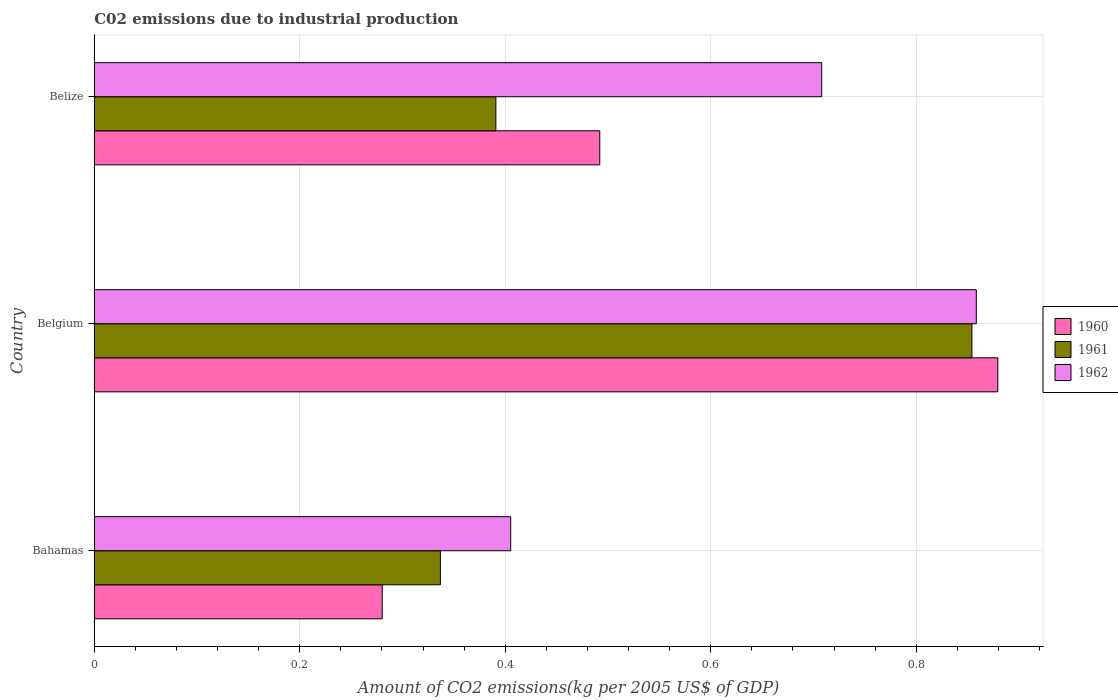How many groups of bars are there?
Your answer should be compact. 3. Are the number of bars on each tick of the Y-axis equal?
Your answer should be very brief. Yes. What is the label of the 1st group of bars from the top?
Your response must be concise. Belize. In how many cases, is the number of bars for a given country not equal to the number of legend labels?
Keep it short and to the point. 0. What is the amount of CO2 emitted due to industrial production in 1960 in Belize?
Keep it short and to the point. 0.49. Across all countries, what is the maximum amount of CO2 emitted due to industrial production in 1961?
Provide a succinct answer. 0.85. Across all countries, what is the minimum amount of CO2 emitted due to industrial production in 1961?
Your answer should be very brief. 0.34. In which country was the amount of CO2 emitted due to industrial production in 1960 maximum?
Your answer should be very brief. Belgium. In which country was the amount of CO2 emitted due to industrial production in 1962 minimum?
Make the answer very short. Bahamas. What is the total amount of CO2 emitted due to industrial production in 1961 in the graph?
Provide a short and direct response. 1.58. What is the difference between the amount of CO2 emitted due to industrial production in 1961 in Bahamas and that in Belgium?
Ensure brevity in your answer.  -0.52. What is the difference between the amount of CO2 emitted due to industrial production in 1961 in Bahamas and the amount of CO2 emitted due to industrial production in 1960 in Belize?
Provide a succinct answer. -0.16. What is the average amount of CO2 emitted due to industrial production in 1960 per country?
Offer a very short reply. 0.55. What is the difference between the amount of CO2 emitted due to industrial production in 1961 and amount of CO2 emitted due to industrial production in 1962 in Bahamas?
Your answer should be compact. -0.07. What is the ratio of the amount of CO2 emitted due to industrial production in 1961 in Bahamas to that in Belgium?
Make the answer very short. 0.39. Is the difference between the amount of CO2 emitted due to industrial production in 1961 in Bahamas and Belgium greater than the difference between the amount of CO2 emitted due to industrial production in 1962 in Bahamas and Belgium?
Your answer should be very brief. No. What is the difference between the highest and the second highest amount of CO2 emitted due to industrial production in 1961?
Provide a short and direct response. 0.46. What is the difference between the highest and the lowest amount of CO2 emitted due to industrial production in 1962?
Provide a succinct answer. 0.45. What does the 1st bar from the bottom in Belize represents?
Keep it short and to the point. 1960. How many bars are there?
Provide a succinct answer. 9. Are all the bars in the graph horizontal?
Keep it short and to the point. Yes. How many countries are there in the graph?
Ensure brevity in your answer.  3. What is the difference between two consecutive major ticks on the X-axis?
Your response must be concise. 0.2. Are the values on the major ticks of X-axis written in scientific E-notation?
Your answer should be very brief. No. Does the graph contain any zero values?
Provide a short and direct response. No. Does the graph contain grids?
Your response must be concise. Yes. How many legend labels are there?
Give a very brief answer. 3. What is the title of the graph?
Your response must be concise. C02 emissions due to industrial production. What is the label or title of the X-axis?
Your answer should be compact. Amount of CO2 emissions(kg per 2005 US$ of GDP). What is the label or title of the Y-axis?
Your response must be concise. Country. What is the Amount of CO2 emissions(kg per 2005 US$ of GDP) of 1960 in Bahamas?
Make the answer very short. 0.28. What is the Amount of CO2 emissions(kg per 2005 US$ of GDP) of 1961 in Bahamas?
Provide a succinct answer. 0.34. What is the Amount of CO2 emissions(kg per 2005 US$ of GDP) of 1962 in Bahamas?
Provide a succinct answer. 0.41. What is the Amount of CO2 emissions(kg per 2005 US$ of GDP) of 1960 in Belgium?
Provide a succinct answer. 0.88. What is the Amount of CO2 emissions(kg per 2005 US$ of GDP) of 1961 in Belgium?
Give a very brief answer. 0.85. What is the Amount of CO2 emissions(kg per 2005 US$ of GDP) in 1962 in Belgium?
Make the answer very short. 0.86. What is the Amount of CO2 emissions(kg per 2005 US$ of GDP) of 1960 in Belize?
Keep it short and to the point. 0.49. What is the Amount of CO2 emissions(kg per 2005 US$ of GDP) of 1961 in Belize?
Offer a very short reply. 0.39. What is the Amount of CO2 emissions(kg per 2005 US$ of GDP) in 1962 in Belize?
Ensure brevity in your answer.  0.71. Across all countries, what is the maximum Amount of CO2 emissions(kg per 2005 US$ of GDP) in 1960?
Your response must be concise. 0.88. Across all countries, what is the maximum Amount of CO2 emissions(kg per 2005 US$ of GDP) in 1961?
Your answer should be compact. 0.85. Across all countries, what is the maximum Amount of CO2 emissions(kg per 2005 US$ of GDP) in 1962?
Give a very brief answer. 0.86. Across all countries, what is the minimum Amount of CO2 emissions(kg per 2005 US$ of GDP) of 1960?
Provide a short and direct response. 0.28. Across all countries, what is the minimum Amount of CO2 emissions(kg per 2005 US$ of GDP) of 1961?
Offer a terse response. 0.34. Across all countries, what is the minimum Amount of CO2 emissions(kg per 2005 US$ of GDP) of 1962?
Give a very brief answer. 0.41. What is the total Amount of CO2 emissions(kg per 2005 US$ of GDP) of 1960 in the graph?
Ensure brevity in your answer.  1.65. What is the total Amount of CO2 emissions(kg per 2005 US$ of GDP) of 1961 in the graph?
Offer a very short reply. 1.58. What is the total Amount of CO2 emissions(kg per 2005 US$ of GDP) of 1962 in the graph?
Offer a very short reply. 1.97. What is the difference between the Amount of CO2 emissions(kg per 2005 US$ of GDP) in 1960 in Bahamas and that in Belgium?
Ensure brevity in your answer.  -0.6. What is the difference between the Amount of CO2 emissions(kg per 2005 US$ of GDP) in 1961 in Bahamas and that in Belgium?
Your answer should be compact. -0.52. What is the difference between the Amount of CO2 emissions(kg per 2005 US$ of GDP) of 1962 in Bahamas and that in Belgium?
Offer a terse response. -0.45. What is the difference between the Amount of CO2 emissions(kg per 2005 US$ of GDP) in 1960 in Bahamas and that in Belize?
Provide a short and direct response. -0.21. What is the difference between the Amount of CO2 emissions(kg per 2005 US$ of GDP) in 1961 in Bahamas and that in Belize?
Provide a succinct answer. -0.05. What is the difference between the Amount of CO2 emissions(kg per 2005 US$ of GDP) in 1962 in Bahamas and that in Belize?
Provide a succinct answer. -0.3. What is the difference between the Amount of CO2 emissions(kg per 2005 US$ of GDP) of 1960 in Belgium and that in Belize?
Ensure brevity in your answer.  0.39. What is the difference between the Amount of CO2 emissions(kg per 2005 US$ of GDP) in 1961 in Belgium and that in Belize?
Your response must be concise. 0.46. What is the difference between the Amount of CO2 emissions(kg per 2005 US$ of GDP) of 1962 in Belgium and that in Belize?
Give a very brief answer. 0.15. What is the difference between the Amount of CO2 emissions(kg per 2005 US$ of GDP) in 1960 in Bahamas and the Amount of CO2 emissions(kg per 2005 US$ of GDP) in 1961 in Belgium?
Ensure brevity in your answer.  -0.57. What is the difference between the Amount of CO2 emissions(kg per 2005 US$ of GDP) in 1960 in Bahamas and the Amount of CO2 emissions(kg per 2005 US$ of GDP) in 1962 in Belgium?
Make the answer very short. -0.58. What is the difference between the Amount of CO2 emissions(kg per 2005 US$ of GDP) of 1961 in Bahamas and the Amount of CO2 emissions(kg per 2005 US$ of GDP) of 1962 in Belgium?
Your answer should be compact. -0.52. What is the difference between the Amount of CO2 emissions(kg per 2005 US$ of GDP) in 1960 in Bahamas and the Amount of CO2 emissions(kg per 2005 US$ of GDP) in 1961 in Belize?
Offer a terse response. -0.11. What is the difference between the Amount of CO2 emissions(kg per 2005 US$ of GDP) of 1960 in Bahamas and the Amount of CO2 emissions(kg per 2005 US$ of GDP) of 1962 in Belize?
Ensure brevity in your answer.  -0.43. What is the difference between the Amount of CO2 emissions(kg per 2005 US$ of GDP) of 1961 in Bahamas and the Amount of CO2 emissions(kg per 2005 US$ of GDP) of 1962 in Belize?
Your answer should be very brief. -0.37. What is the difference between the Amount of CO2 emissions(kg per 2005 US$ of GDP) in 1960 in Belgium and the Amount of CO2 emissions(kg per 2005 US$ of GDP) in 1961 in Belize?
Provide a short and direct response. 0.49. What is the difference between the Amount of CO2 emissions(kg per 2005 US$ of GDP) in 1960 in Belgium and the Amount of CO2 emissions(kg per 2005 US$ of GDP) in 1962 in Belize?
Provide a succinct answer. 0.17. What is the difference between the Amount of CO2 emissions(kg per 2005 US$ of GDP) in 1961 in Belgium and the Amount of CO2 emissions(kg per 2005 US$ of GDP) in 1962 in Belize?
Your answer should be compact. 0.15. What is the average Amount of CO2 emissions(kg per 2005 US$ of GDP) in 1960 per country?
Provide a short and direct response. 0.55. What is the average Amount of CO2 emissions(kg per 2005 US$ of GDP) in 1961 per country?
Give a very brief answer. 0.53. What is the average Amount of CO2 emissions(kg per 2005 US$ of GDP) in 1962 per country?
Keep it short and to the point. 0.66. What is the difference between the Amount of CO2 emissions(kg per 2005 US$ of GDP) in 1960 and Amount of CO2 emissions(kg per 2005 US$ of GDP) in 1961 in Bahamas?
Give a very brief answer. -0.06. What is the difference between the Amount of CO2 emissions(kg per 2005 US$ of GDP) of 1960 and Amount of CO2 emissions(kg per 2005 US$ of GDP) of 1962 in Bahamas?
Offer a terse response. -0.13. What is the difference between the Amount of CO2 emissions(kg per 2005 US$ of GDP) in 1961 and Amount of CO2 emissions(kg per 2005 US$ of GDP) in 1962 in Bahamas?
Give a very brief answer. -0.07. What is the difference between the Amount of CO2 emissions(kg per 2005 US$ of GDP) in 1960 and Amount of CO2 emissions(kg per 2005 US$ of GDP) in 1961 in Belgium?
Your answer should be compact. 0.03. What is the difference between the Amount of CO2 emissions(kg per 2005 US$ of GDP) of 1960 and Amount of CO2 emissions(kg per 2005 US$ of GDP) of 1962 in Belgium?
Keep it short and to the point. 0.02. What is the difference between the Amount of CO2 emissions(kg per 2005 US$ of GDP) in 1961 and Amount of CO2 emissions(kg per 2005 US$ of GDP) in 1962 in Belgium?
Your answer should be compact. -0. What is the difference between the Amount of CO2 emissions(kg per 2005 US$ of GDP) in 1960 and Amount of CO2 emissions(kg per 2005 US$ of GDP) in 1961 in Belize?
Your answer should be very brief. 0.1. What is the difference between the Amount of CO2 emissions(kg per 2005 US$ of GDP) in 1960 and Amount of CO2 emissions(kg per 2005 US$ of GDP) in 1962 in Belize?
Give a very brief answer. -0.22. What is the difference between the Amount of CO2 emissions(kg per 2005 US$ of GDP) of 1961 and Amount of CO2 emissions(kg per 2005 US$ of GDP) of 1962 in Belize?
Your answer should be compact. -0.32. What is the ratio of the Amount of CO2 emissions(kg per 2005 US$ of GDP) of 1960 in Bahamas to that in Belgium?
Provide a succinct answer. 0.32. What is the ratio of the Amount of CO2 emissions(kg per 2005 US$ of GDP) in 1961 in Bahamas to that in Belgium?
Give a very brief answer. 0.39. What is the ratio of the Amount of CO2 emissions(kg per 2005 US$ of GDP) in 1962 in Bahamas to that in Belgium?
Give a very brief answer. 0.47. What is the ratio of the Amount of CO2 emissions(kg per 2005 US$ of GDP) in 1960 in Bahamas to that in Belize?
Keep it short and to the point. 0.57. What is the ratio of the Amount of CO2 emissions(kg per 2005 US$ of GDP) in 1961 in Bahamas to that in Belize?
Your answer should be compact. 0.86. What is the ratio of the Amount of CO2 emissions(kg per 2005 US$ of GDP) in 1962 in Bahamas to that in Belize?
Your answer should be very brief. 0.57. What is the ratio of the Amount of CO2 emissions(kg per 2005 US$ of GDP) in 1960 in Belgium to that in Belize?
Your response must be concise. 1.79. What is the ratio of the Amount of CO2 emissions(kg per 2005 US$ of GDP) of 1961 in Belgium to that in Belize?
Offer a very short reply. 2.19. What is the ratio of the Amount of CO2 emissions(kg per 2005 US$ of GDP) in 1962 in Belgium to that in Belize?
Offer a terse response. 1.21. What is the difference between the highest and the second highest Amount of CO2 emissions(kg per 2005 US$ of GDP) in 1960?
Provide a short and direct response. 0.39. What is the difference between the highest and the second highest Amount of CO2 emissions(kg per 2005 US$ of GDP) of 1961?
Provide a succinct answer. 0.46. What is the difference between the highest and the second highest Amount of CO2 emissions(kg per 2005 US$ of GDP) in 1962?
Your response must be concise. 0.15. What is the difference between the highest and the lowest Amount of CO2 emissions(kg per 2005 US$ of GDP) of 1960?
Ensure brevity in your answer.  0.6. What is the difference between the highest and the lowest Amount of CO2 emissions(kg per 2005 US$ of GDP) in 1961?
Provide a succinct answer. 0.52. What is the difference between the highest and the lowest Amount of CO2 emissions(kg per 2005 US$ of GDP) of 1962?
Offer a terse response. 0.45. 